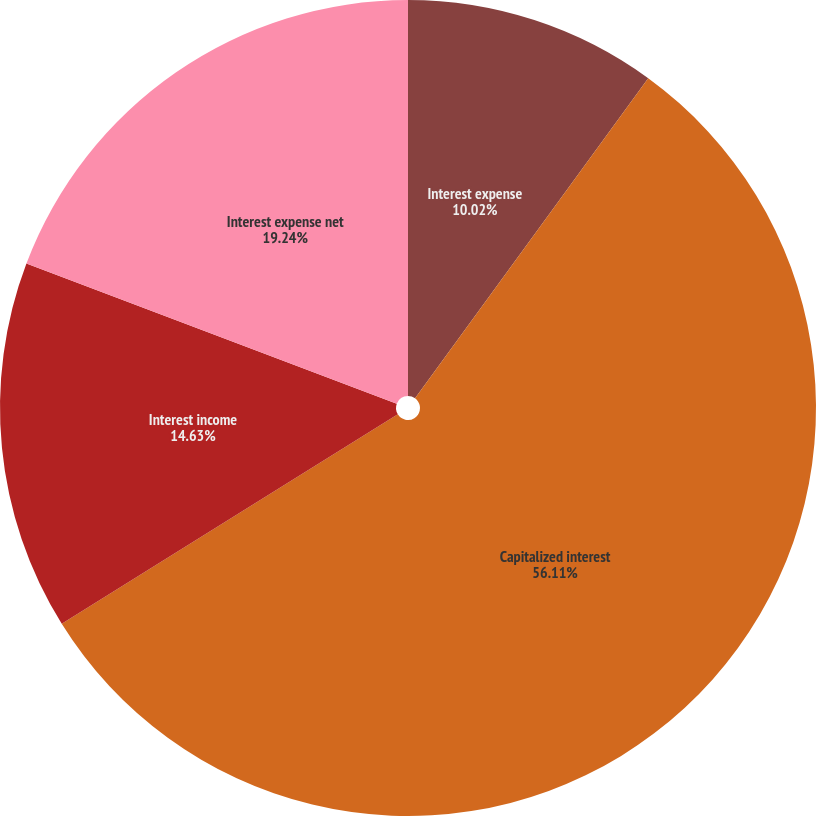<chart> <loc_0><loc_0><loc_500><loc_500><pie_chart><fcel>Interest expense<fcel>Capitalized interest<fcel>Interest income<fcel>Interest expense net<nl><fcel>10.02%<fcel>56.11%<fcel>14.63%<fcel>19.24%<nl></chart> 